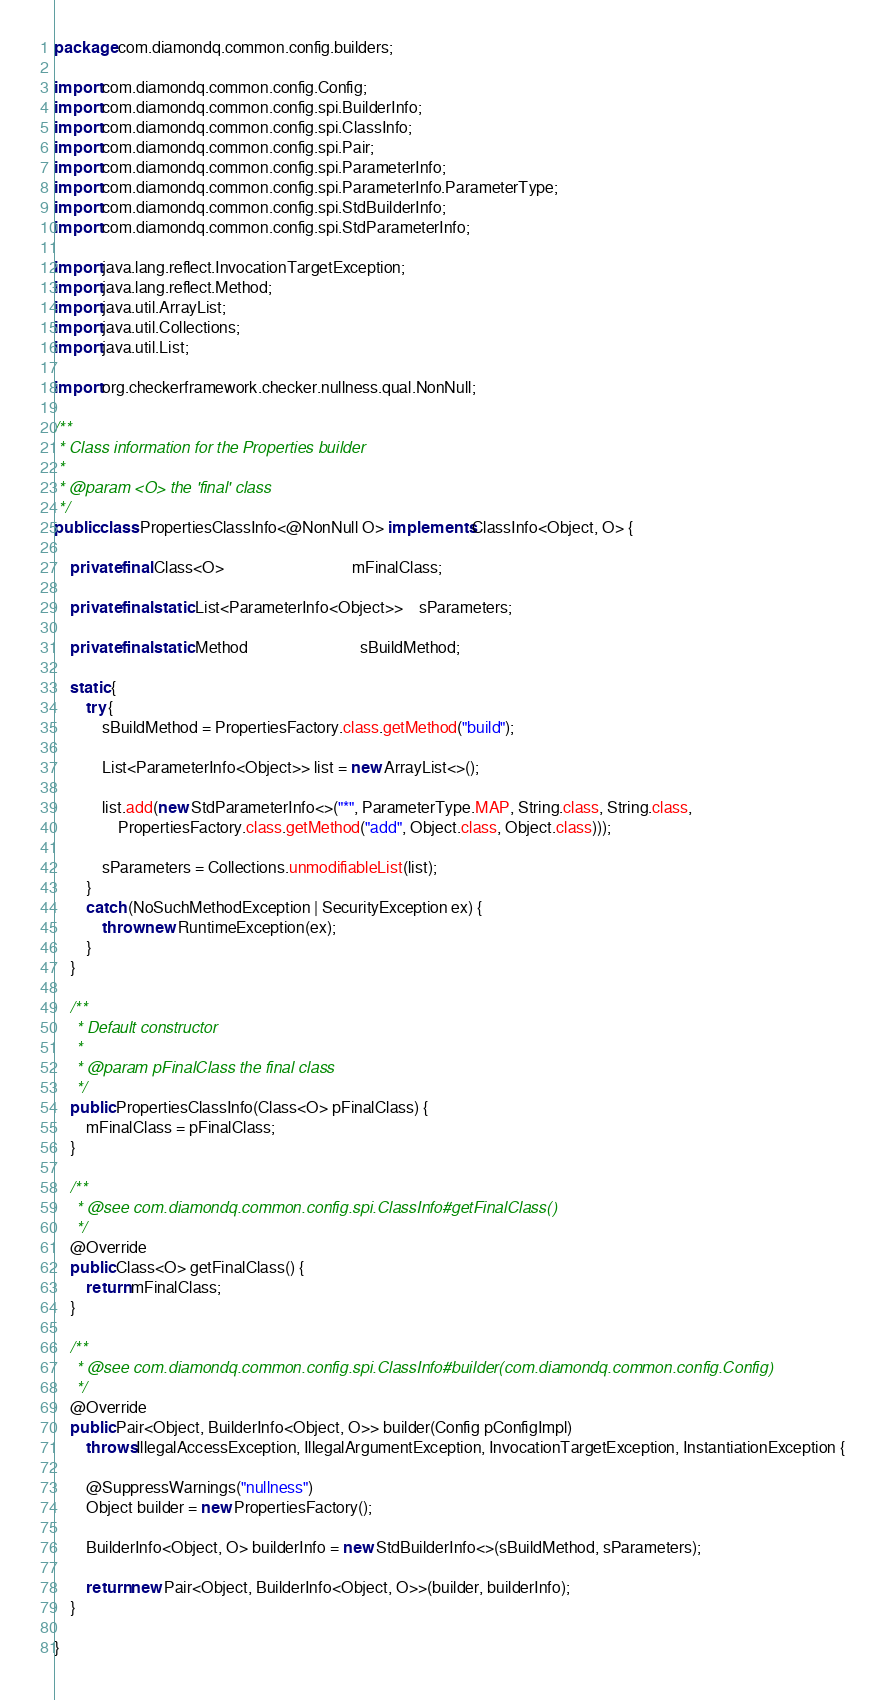<code> <loc_0><loc_0><loc_500><loc_500><_Java_>package com.diamondq.common.config.builders;

import com.diamondq.common.config.Config;
import com.diamondq.common.config.spi.BuilderInfo;
import com.diamondq.common.config.spi.ClassInfo;
import com.diamondq.common.config.spi.Pair;
import com.diamondq.common.config.spi.ParameterInfo;
import com.diamondq.common.config.spi.ParameterInfo.ParameterType;
import com.diamondq.common.config.spi.StdBuilderInfo;
import com.diamondq.common.config.spi.StdParameterInfo;

import java.lang.reflect.InvocationTargetException;
import java.lang.reflect.Method;
import java.util.ArrayList;
import java.util.Collections;
import java.util.List;

import org.checkerframework.checker.nullness.qual.NonNull;

/**
 * Class information for the Properties builder
 *
 * @param <O> the 'final' class
 */
public class PropertiesClassInfo<@NonNull O> implements ClassInfo<Object, O> {

	private final Class<O>								mFinalClass;

	private final static List<ParameterInfo<Object>>	sParameters;

	private final static Method							sBuildMethod;

	static {
		try {
			sBuildMethod = PropertiesFactory.class.getMethod("build");

			List<ParameterInfo<Object>> list = new ArrayList<>();

			list.add(new StdParameterInfo<>("*", ParameterType.MAP, String.class, String.class,
				PropertiesFactory.class.getMethod("add", Object.class, Object.class)));

			sParameters = Collections.unmodifiableList(list);
		}
		catch (NoSuchMethodException | SecurityException ex) {
			throw new RuntimeException(ex);
		}
	}

	/**
	 * Default constructor
	 *
	 * @param pFinalClass the final class
	 */
	public PropertiesClassInfo(Class<O> pFinalClass) {
		mFinalClass = pFinalClass;
	}

	/**
	 * @see com.diamondq.common.config.spi.ClassInfo#getFinalClass()
	 */
	@Override
	public Class<O> getFinalClass() {
		return mFinalClass;
	}

	/**
	 * @see com.diamondq.common.config.spi.ClassInfo#builder(com.diamondq.common.config.Config)
	 */
	@Override
	public Pair<Object, BuilderInfo<Object, O>> builder(Config pConfigImpl)
		throws IllegalAccessException, IllegalArgumentException, InvocationTargetException, InstantiationException {

		@SuppressWarnings("nullness")
		Object builder = new PropertiesFactory();

		BuilderInfo<Object, O> builderInfo = new StdBuilderInfo<>(sBuildMethod, sParameters);

		return new Pair<Object, BuilderInfo<Object, O>>(builder, builderInfo);
	}

}
</code> 